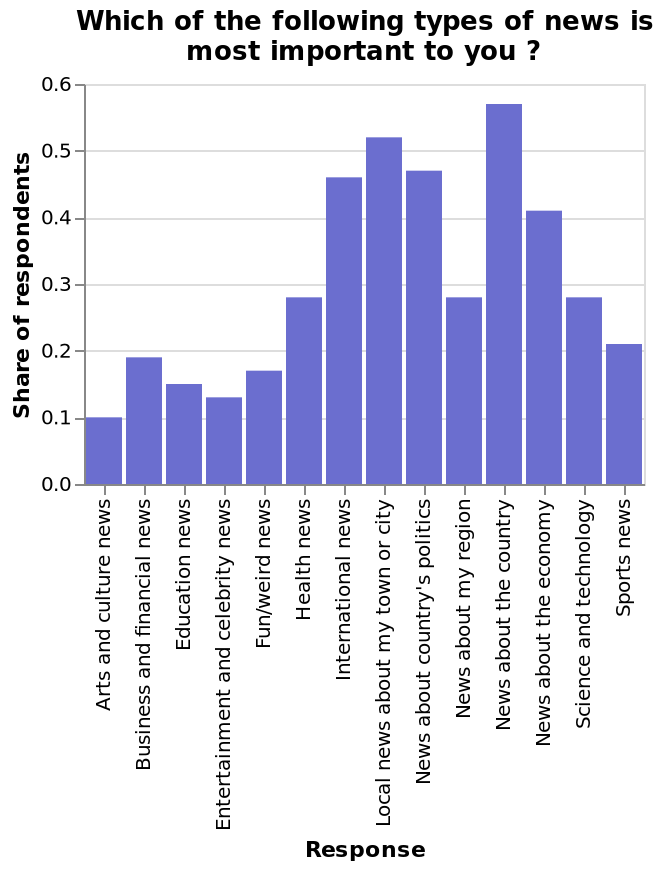<image>
What is the range of the y-axis in the bar diagram?  The y-axis of the bar diagram ranges from 0.0 to 0.6. What types of news are considered less important in comparison to traditional types of news?  Celebrity, sports, and fun news are considered less important. What does the y-axis measure in the bar diagram?  The y-axis in the bar diagram measures the share of respondents along a scale, ranging from 0.0 to 0.6. 